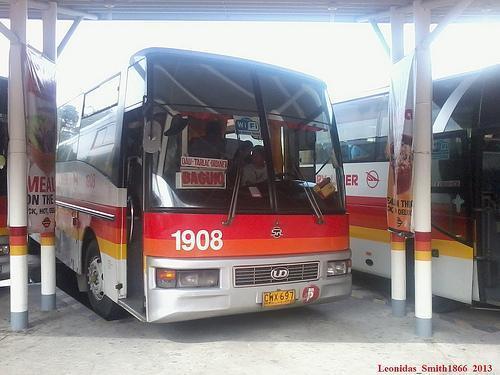How many windshield wipers Are there?
Give a very brief answer. 2. How many busses do you see?
Give a very brief answer. 2. 